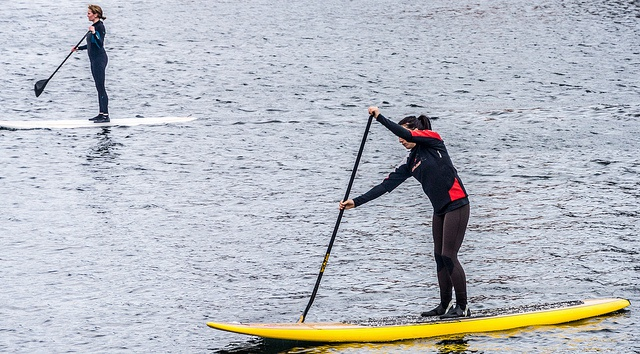Describe the objects in this image and their specific colors. I can see people in lightgray, black, gray, and red tones, surfboard in lightgray, gold, and khaki tones, people in lightgray, black, navy, and gray tones, and surfboard in lightgray, white, darkgray, and gray tones in this image. 